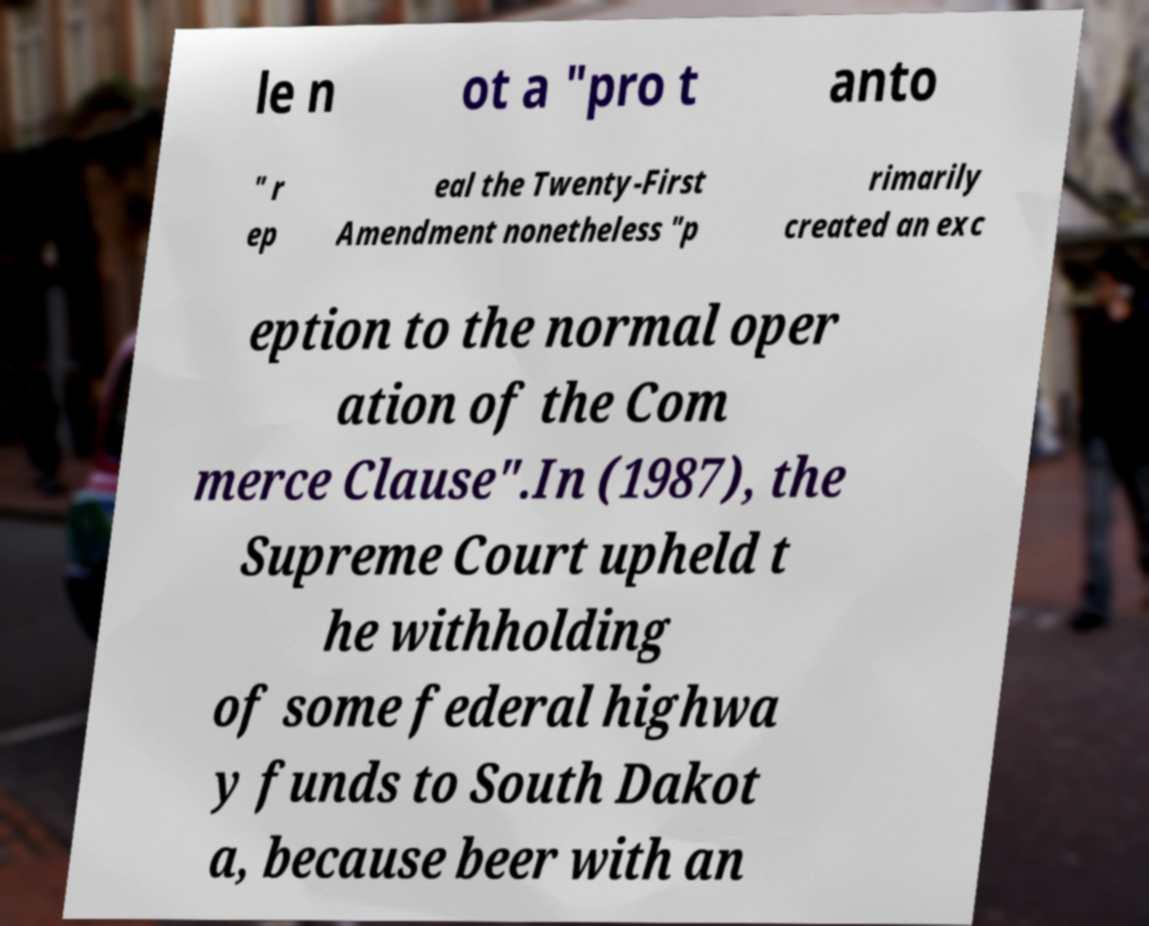What messages or text are displayed in this image? I need them in a readable, typed format. le n ot a "pro t anto " r ep eal the Twenty-First Amendment nonetheless "p rimarily created an exc eption to the normal oper ation of the Com merce Clause".In (1987), the Supreme Court upheld t he withholding of some federal highwa y funds to South Dakot a, because beer with an 